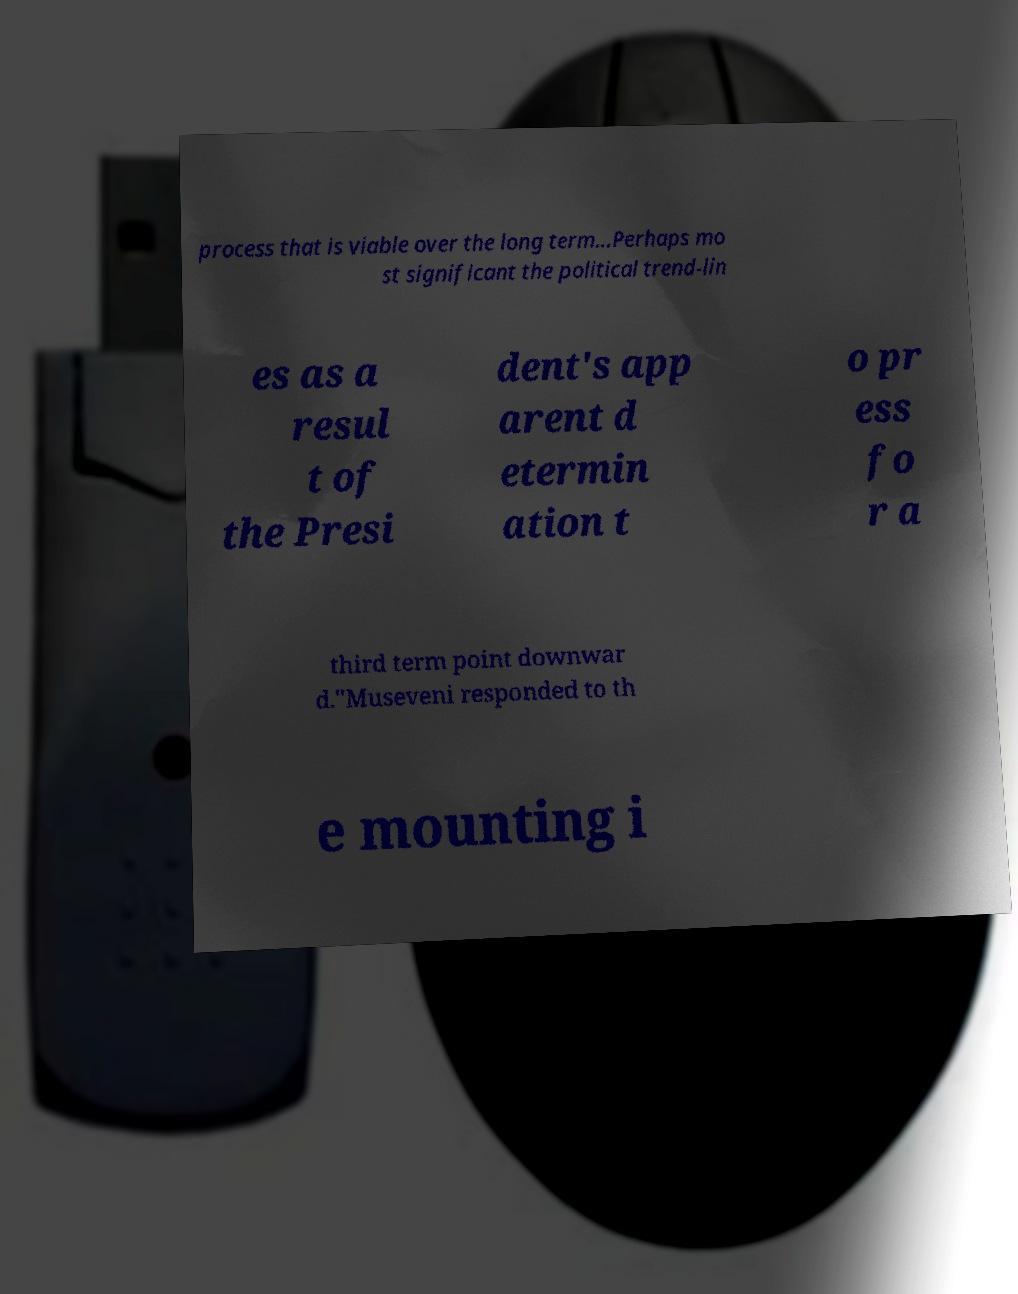Can you accurately transcribe the text from the provided image for me? process that is viable over the long term...Perhaps mo st significant the political trend-lin es as a resul t of the Presi dent's app arent d etermin ation t o pr ess fo r a third term point downwar d."Museveni responded to th e mounting i 